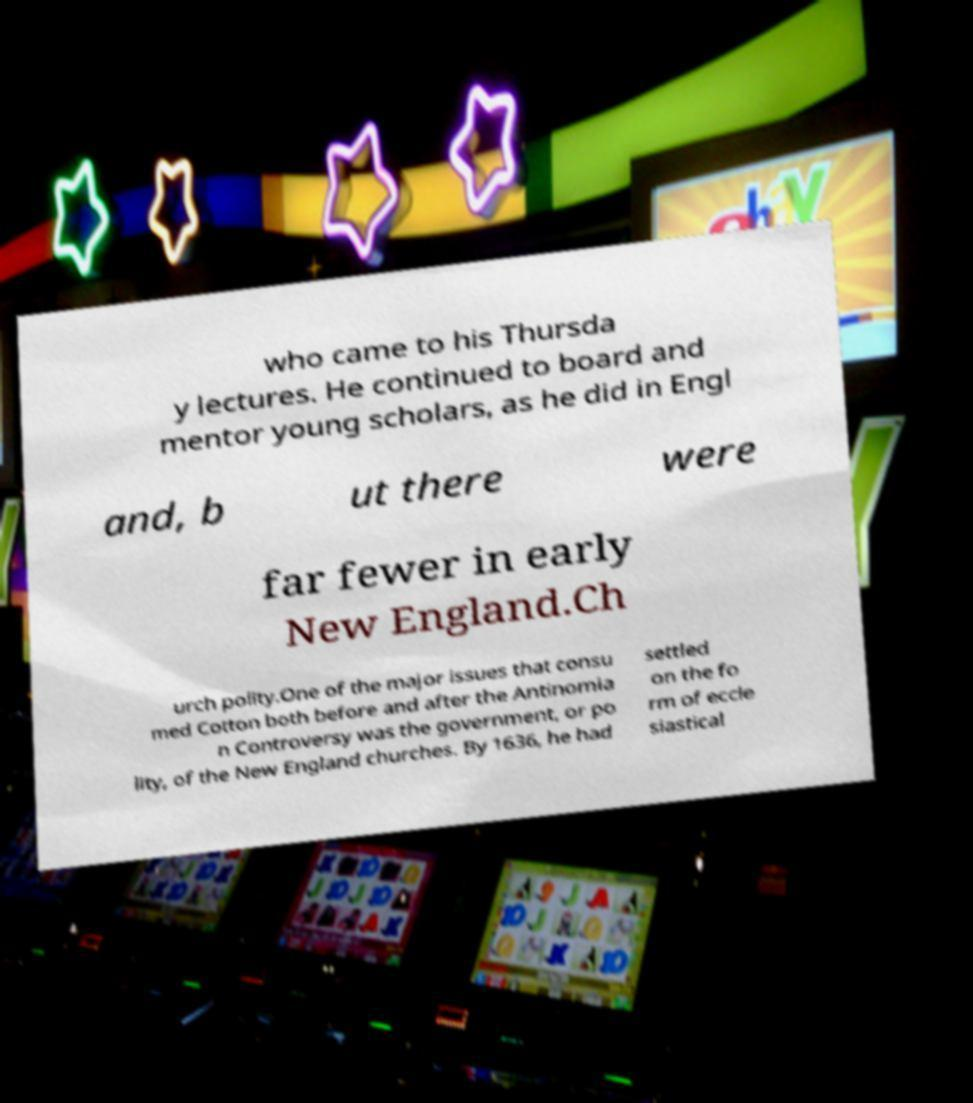Could you assist in decoding the text presented in this image and type it out clearly? who came to his Thursda y lectures. He continued to board and mentor young scholars, as he did in Engl and, b ut there were far fewer in early New England.Ch urch polity.One of the major issues that consu med Cotton both before and after the Antinomia n Controversy was the government, or po lity, of the New England churches. By 1636, he had settled on the fo rm of eccle siastical 